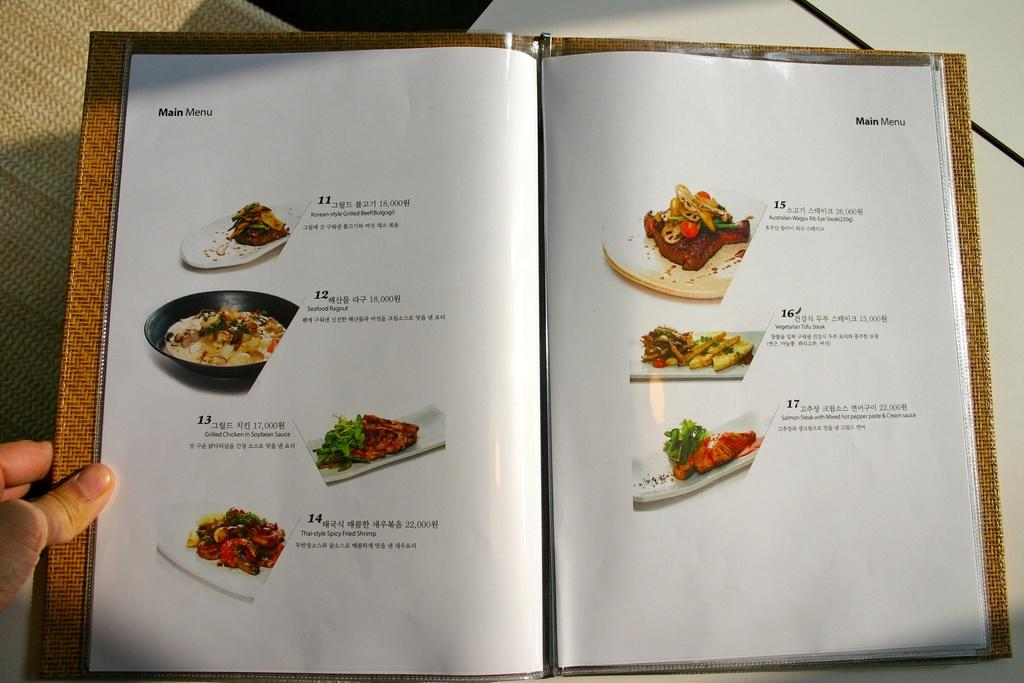What is the main object in the image? There is a menu book in the image. Where is the menu book located? The menu book is present on a table. What information can be found in the menu book? The menu book contains pictures of food items and descriptions of the food items. Whose hand is visible in the image? There is a person's hand visible on the left side of the image. What type of sand can be seen on the menu book in the image? There is no sand present on the menu book in the image. What kind of beast is depicted on the menu book in the image? There are no beasts depicted on the menu book in the image; it contains pictures of food items. 